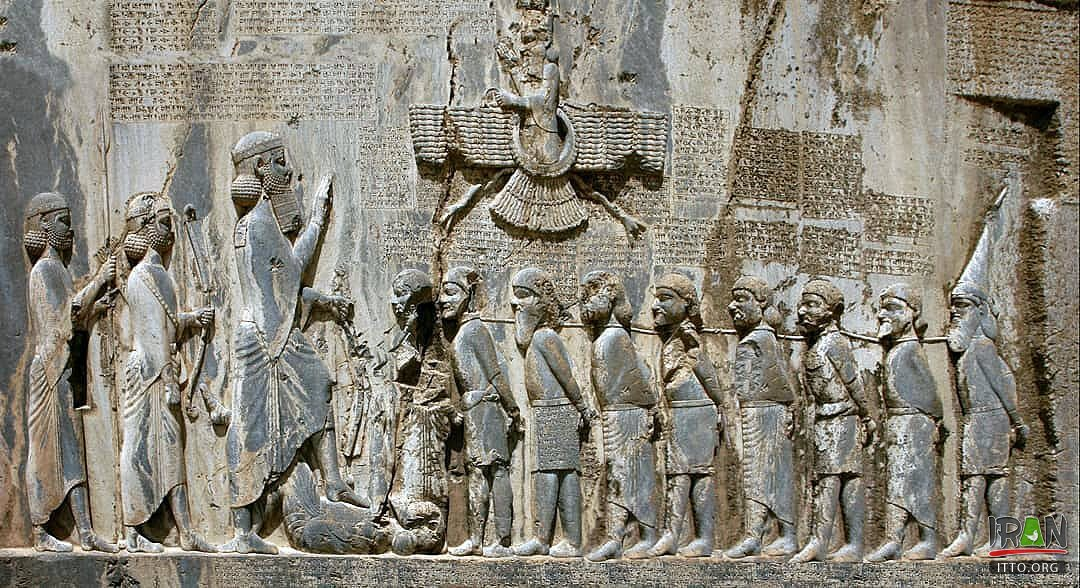What are the key elements in this picture? The image features the ancient Behistun Inscription, an essential archaeological artifact located on Mount Behistun in Iran. It dates back to the reign of Darius the Great, who can be seen in the central relief exerting dominance over a subdued figure, symbolizing his power. This monumental rock relief portrays Darius with a group of nine figures lined up behind him, each representing conquered peoples signifying the vastness of the Persian Empire. The inscription above and around the figures is crucial as it's written in three different languages—Old Persian, Elamite, and Babylonian, highlighting the multicultural aspects of the empire. These scripts have provided invaluable information about the languages and administration of that era. The artwork serves not only as a political statement about Darius's legitimacy and conquests but also as a linguistic artifact pivotal to understanding ancient Near Eastern civilizations. 